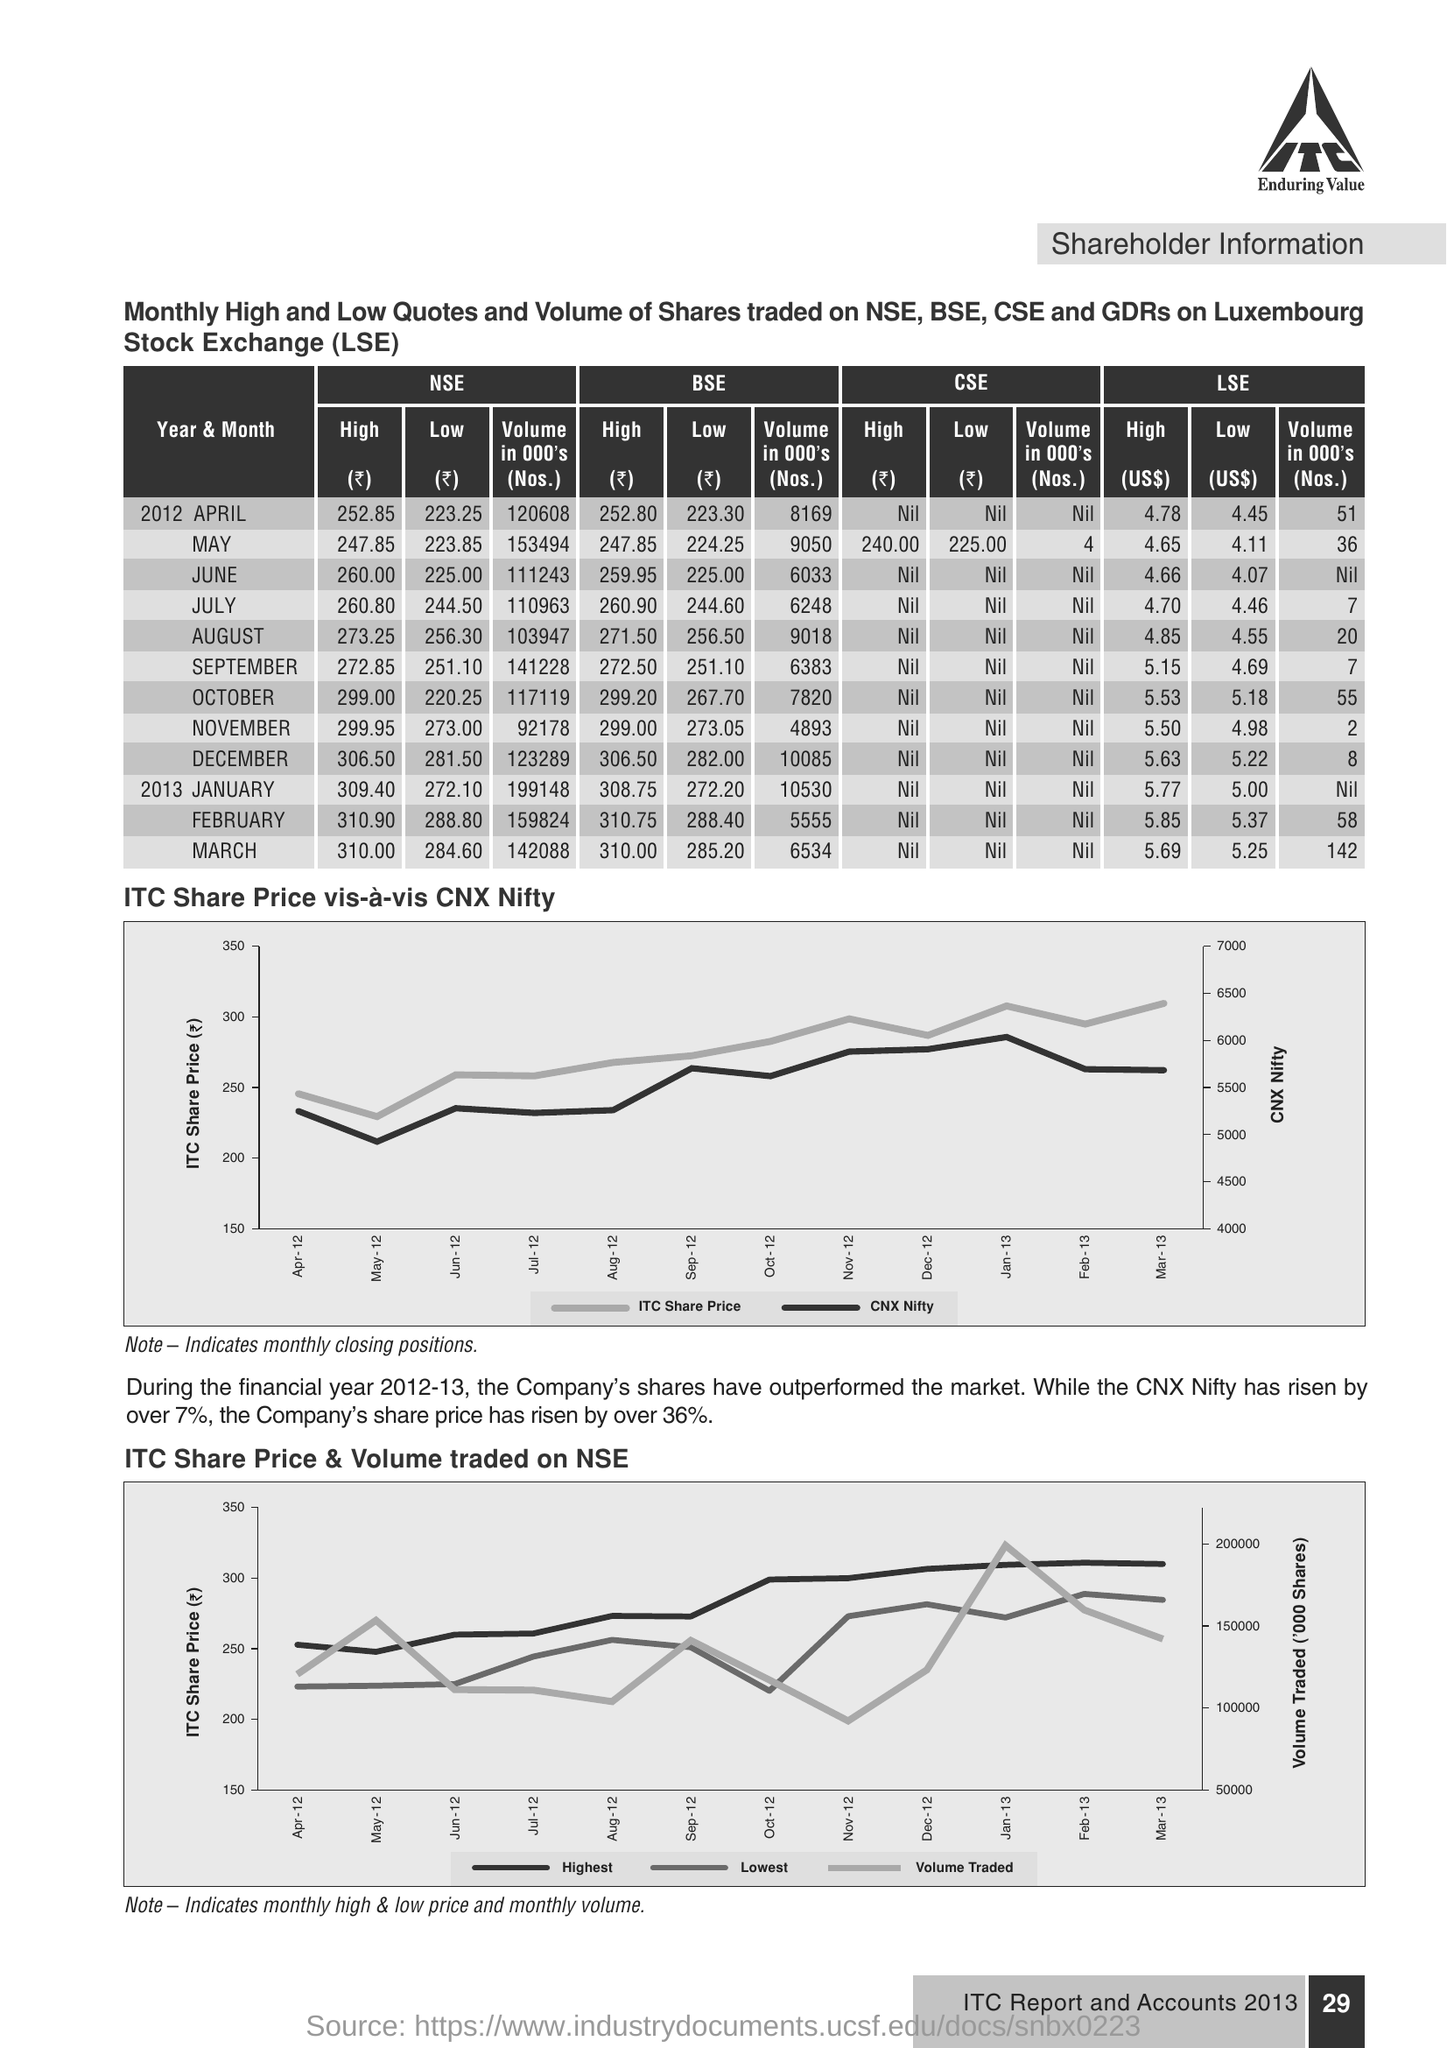Give some essential details in this illustration. In May, the amount of NSE volume was 153,494. This document contains information on shareholder information. The high amount of BSE in August was 271.50. 